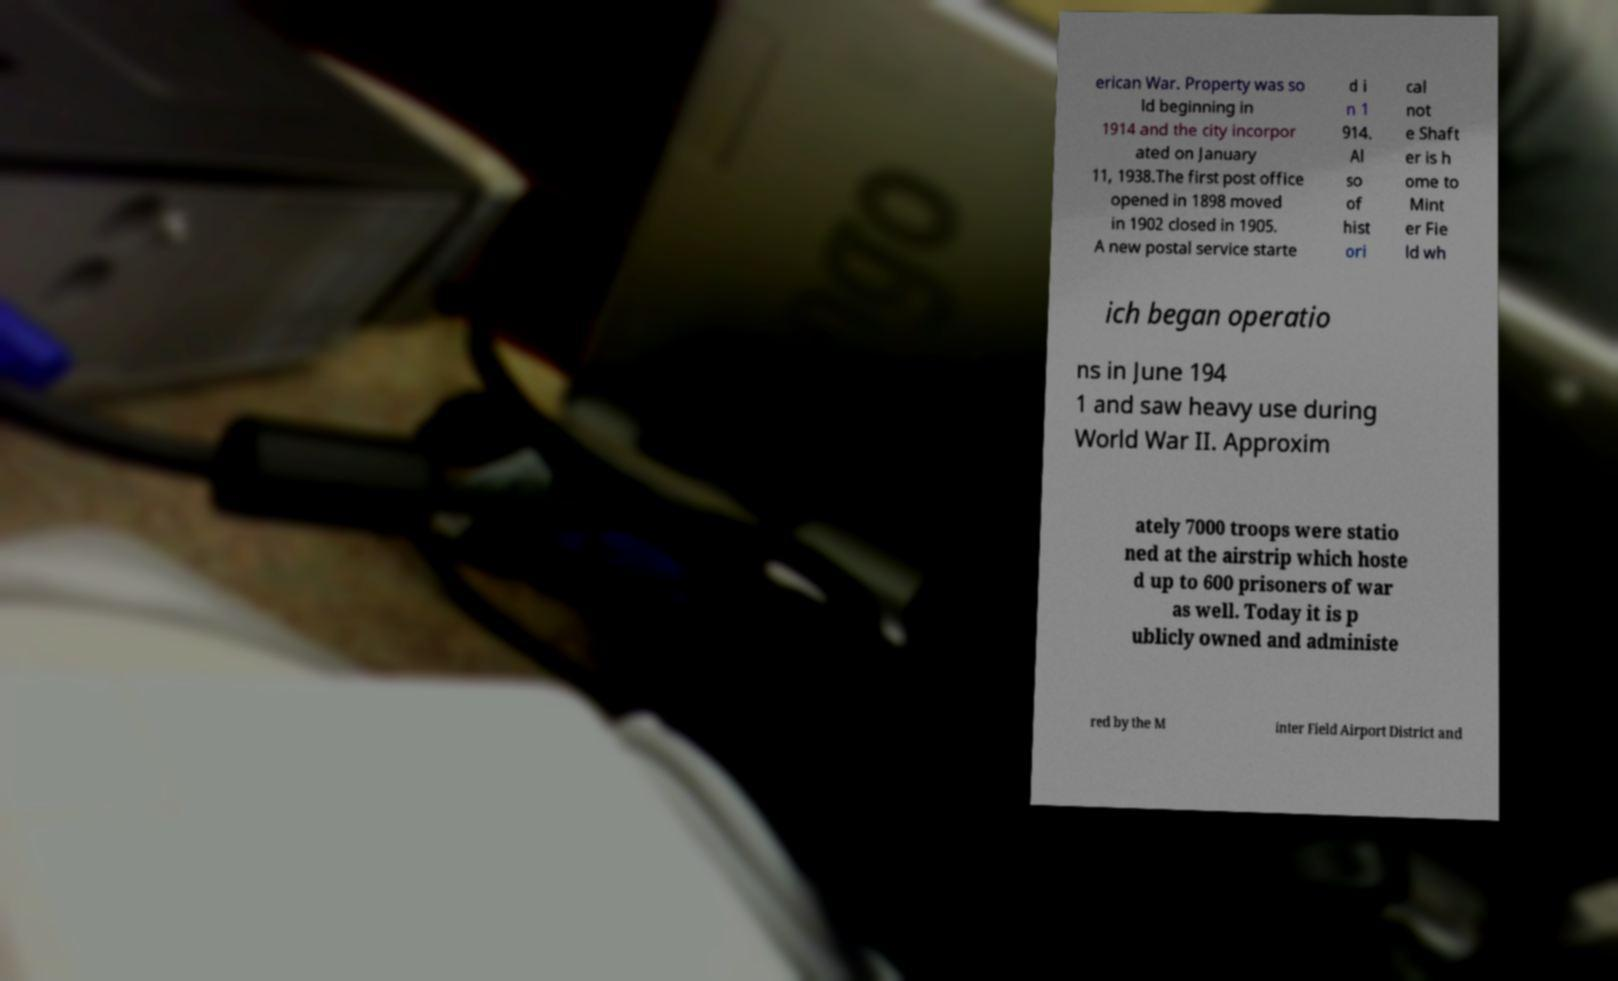Can you read and provide the text displayed in the image?This photo seems to have some interesting text. Can you extract and type it out for me? erican War. Property was so ld beginning in 1914 and the city incorpor ated on January 11, 1938.The first post office opened in 1898 moved in 1902 closed in 1905. A new postal service starte d i n 1 914. Al so of hist ori cal not e Shaft er is h ome to Mint er Fie ld wh ich began operatio ns in June 194 1 and saw heavy use during World War II. Approxim ately 7000 troops were statio ned at the airstrip which hoste d up to 600 prisoners of war as well. Today it is p ublicly owned and administe red by the M inter Field Airport District and 